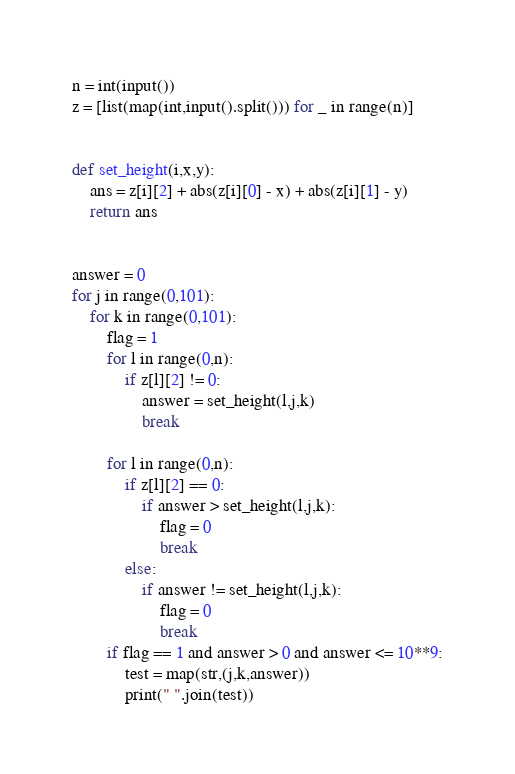Convert code to text. <code><loc_0><loc_0><loc_500><loc_500><_Python_>n = int(input())
z = [list(map(int,input().split())) for _ in range(n)]


def set_height(i,x,y):
	ans = z[i][2] + abs(z[i][0] - x) + abs(z[i][1] - y)
	return ans


answer = 0
for j in range(0,101):
	for k in range(0,101):
		flag = 1
		for l in range(0,n):
			if z[l][2] != 0:
				answer = set_height(l,j,k)
				break

		for l in range(0,n):
			if z[l][2] == 0:
				if answer > set_height(l,j,k):	
					flag = 0
					break
			else:
				if answer != set_height(l,j,k):
					flag = 0
					break
		if flag == 1 and answer > 0 and answer <= 10**9:
			test = map(str,(j,k,answer))
			print(" ".join(test))
</code> 